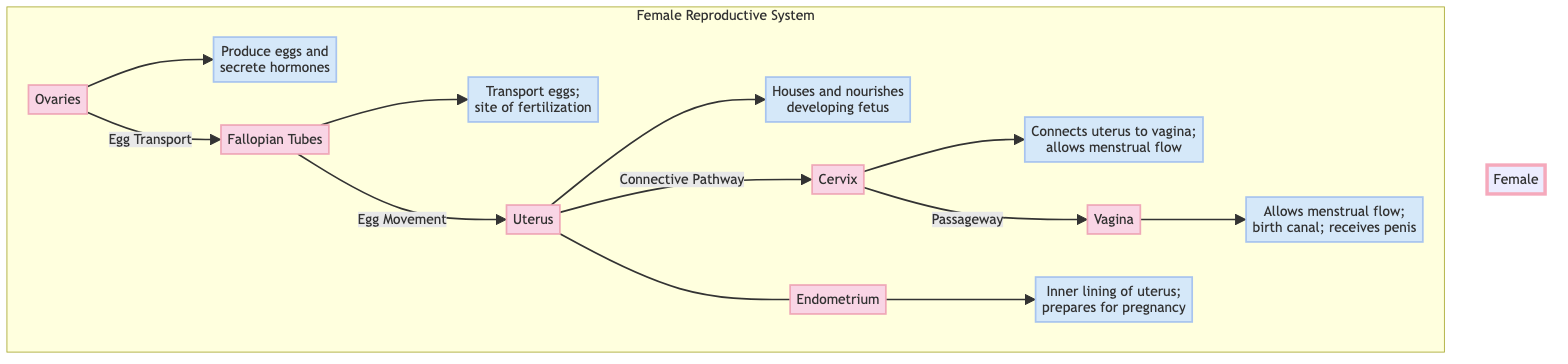What organ produces eggs and hormones? The diagram specifically labels the "Ovaries" as the organ responsible for producing eggs and secreting hormones. This is indicated through the directional connection from the ovaries to the function annotation that describes its role.
Answer: Ovaries How many main reproductive organs are illustrated? By counting the labeled shapes in the "Female Reproductive System" subgraph, we identify six organ nodes: Ovaries, Fallopian Tubes, Uterus, Cervix, Vagina, and Endometrium. Thus, the total is six.
Answer: 6 What does the cervix connect? The labeled pathways show that the "Cervix" connects the "Uterus" to the "Vagina." This connection is clearly indicated in the diagram where the cervix is represented with an arrow pointing towards both the uterus and vagina, signifying its role as a connector.
Answer: Uterus and Vagina Which organ is responsible for housing and nourishing a developing fetus? The diagram provides the role of the "Uterus" explicitly as the organ that houses and nourishes a developing fetus. This is detailed in the function annotation connected to the uterus.
Answer: Uterus What is the function of the endometrium? The diagram explains that the "Endometrium" serves as the inner lining of the uterus and that it prepares for pregnancy. This is part of the labeled information directly associated with the endometrium within the diagram.
Answer: Prepares for pregnancy Which tube serves as the site of fertilization? The flowchart identifies the "Fallopian Tubes" as the site of fertilization and also indicates the function relating to egg transport. It is clear from the labeled section for the fallopian tubes in the diagram.
Answer: Fallopian Tubes What role does the vagina play during birth? The function of the "Vagina" is highlighted as serving multiple roles, including being the birth canal. The directional flow to the vagina emphasizes this function in the diagram.
Answer: Birth canal 